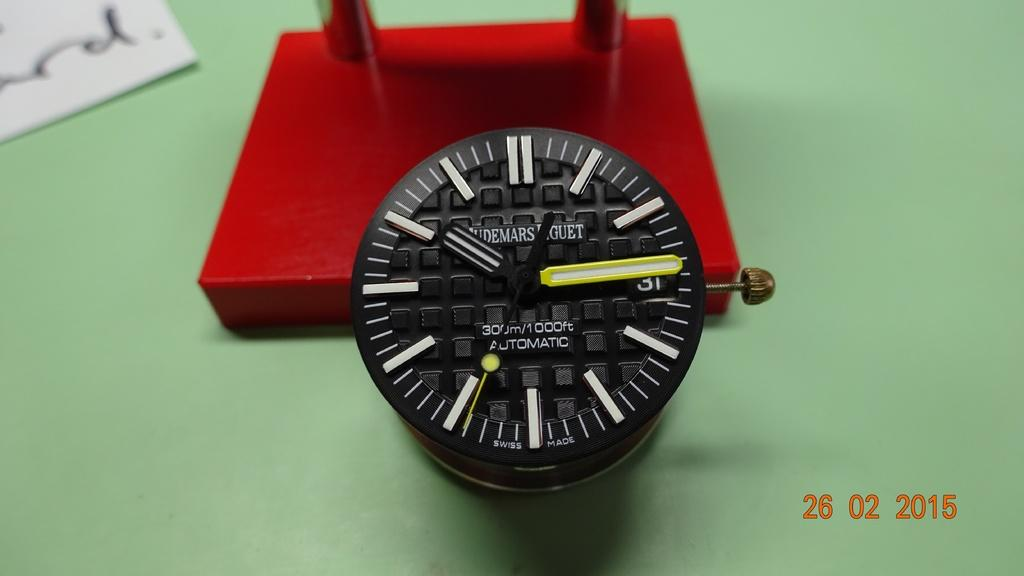<image>
Create a compact narrative representing the image presented. a black and white watch that is Automatic and reads 300m/1000ft 